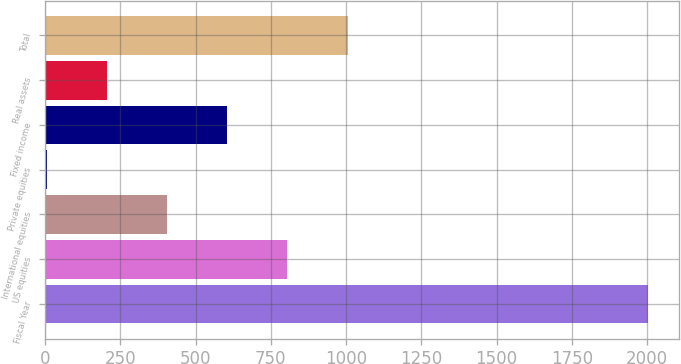<chart> <loc_0><loc_0><loc_500><loc_500><bar_chart><fcel>Fiscal Year<fcel>US equities<fcel>International equities<fcel>Private equities<fcel>Fixed income<fcel>Real assets<fcel>Total<nl><fcel>2005<fcel>805<fcel>405<fcel>5<fcel>605<fcel>205<fcel>1005<nl></chart> 